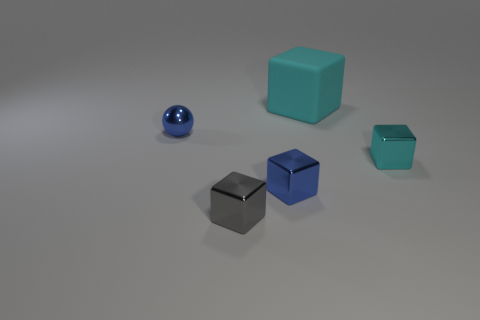Subtract all red blocks. Subtract all yellow balls. How many blocks are left? 4 Add 3 big red cubes. How many objects exist? 8 Subtract all cubes. How many objects are left? 1 Add 5 blue metal spheres. How many blue metal spheres exist? 6 Subtract 0 purple balls. How many objects are left? 5 Subtract all small purple metal balls. Subtract all blue objects. How many objects are left? 3 Add 1 tiny blue balls. How many tiny blue balls are left? 2 